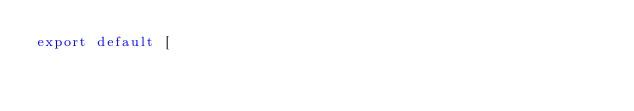Convert code to text. <code><loc_0><loc_0><loc_500><loc_500><_TypeScript_>export default [</code> 